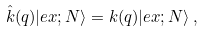Convert formula to latex. <formula><loc_0><loc_0><loc_500><loc_500>\hat { k } ( q ) | e x ; N \rangle = k ( q ) | e x ; N \rangle \, ,</formula> 